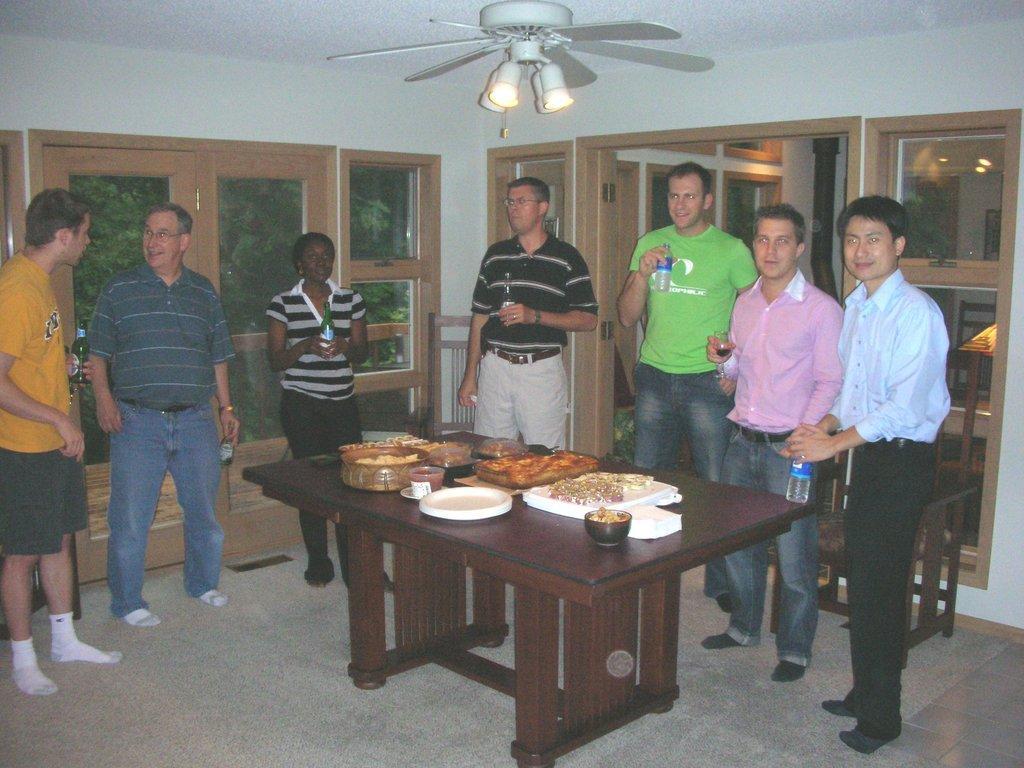In one or two sentences, can you explain what this image depicts? This is a room where we have a group of people, someone holding the bottles and the other guy holding the glass and there is a table on which there are some food items and there is a fan and the lights and behind them there is a door and some windows. 